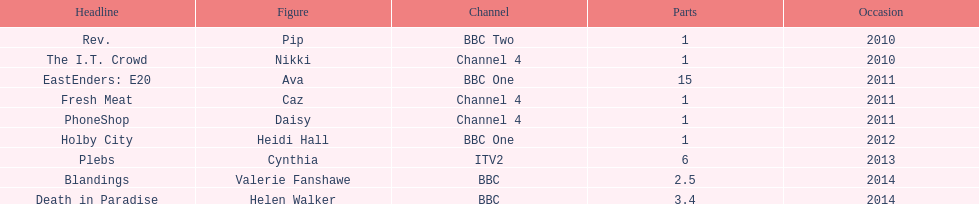What is the only role she played with broadcaster itv2? Cynthia. Write the full table. {'header': ['Headline', 'Figure', 'Channel', 'Parts', 'Occasion'], 'rows': [['Rev.', 'Pip', 'BBC Two', '1', '2010'], ['The I.T. Crowd', 'Nikki', 'Channel 4', '1', '2010'], ['EastEnders: E20', 'Ava', 'BBC One', '15', '2011'], ['Fresh Meat', 'Caz', 'Channel 4', '1', '2011'], ['PhoneShop', 'Daisy', 'Channel 4', '1', '2011'], ['Holby City', 'Heidi Hall', 'BBC One', '1', '2012'], ['Plebs', 'Cynthia', 'ITV2', '6', '2013'], ['Blandings', 'Valerie Fanshawe', 'BBC', '2.5', '2014'], ['Death in Paradise', 'Helen Walker', 'BBC', '3.4', '2014']]} 